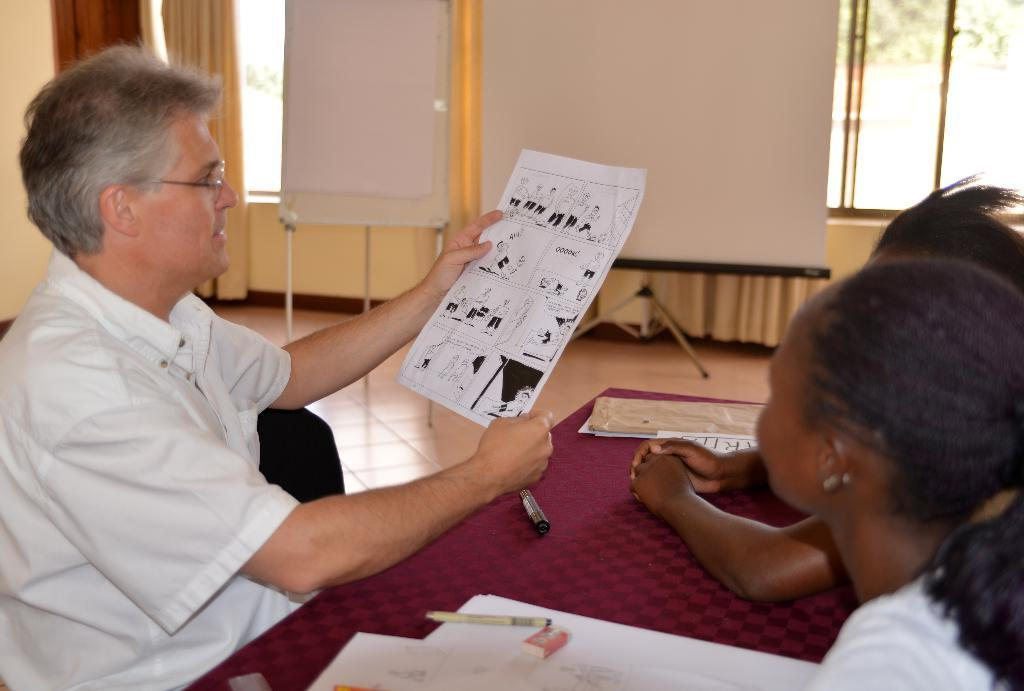How many people are in the image? There are persons in the image, but the exact number is not specified. What objects are related to writing in the image? There are papers, pens, and an eraser in the image. What can be seen in the background of the image? There is a wall, curtains, glass windows, and boards in the background of the image. What type of star can be seen shining through the glove in the image? There is no star or glove present in the image. 